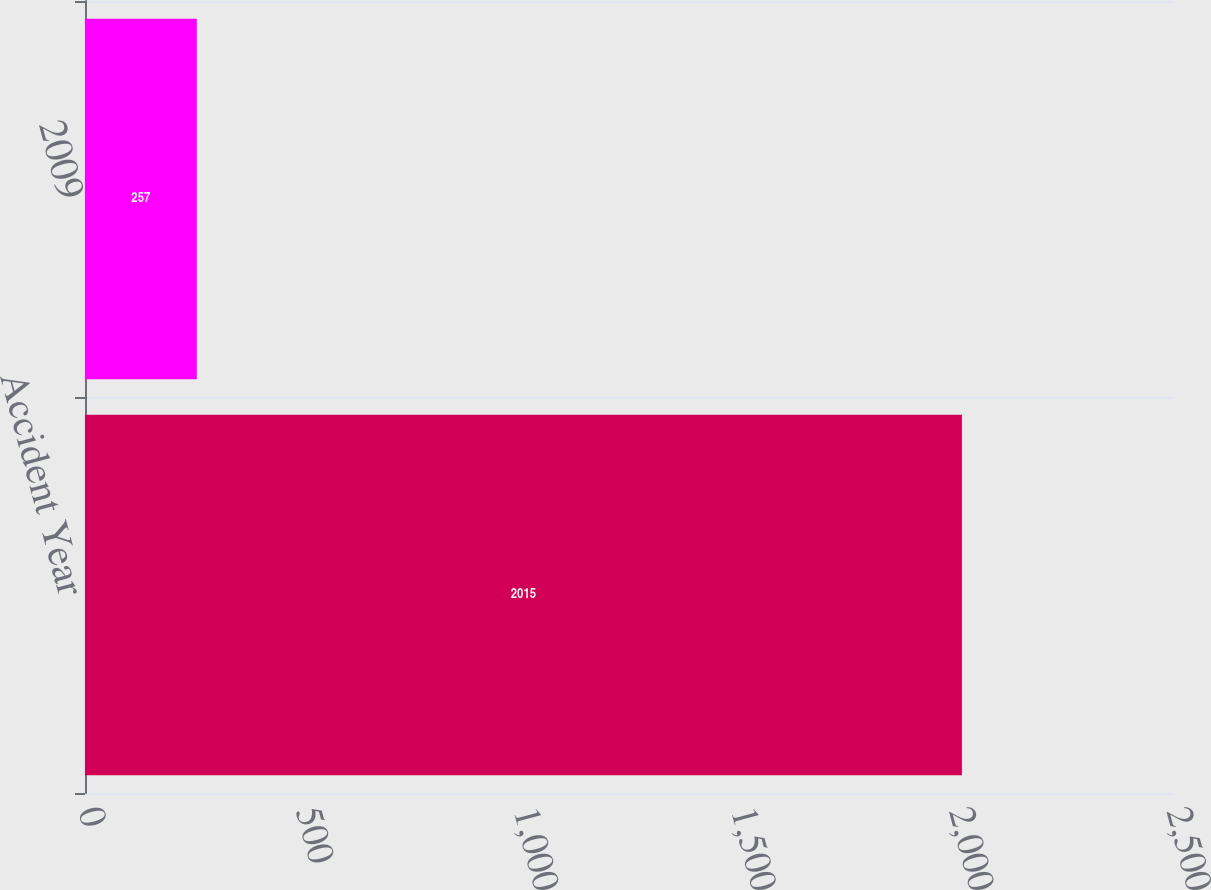Convert chart to OTSL. <chart><loc_0><loc_0><loc_500><loc_500><bar_chart><fcel>Accident Year<fcel>2009<nl><fcel>2015<fcel>257<nl></chart> 